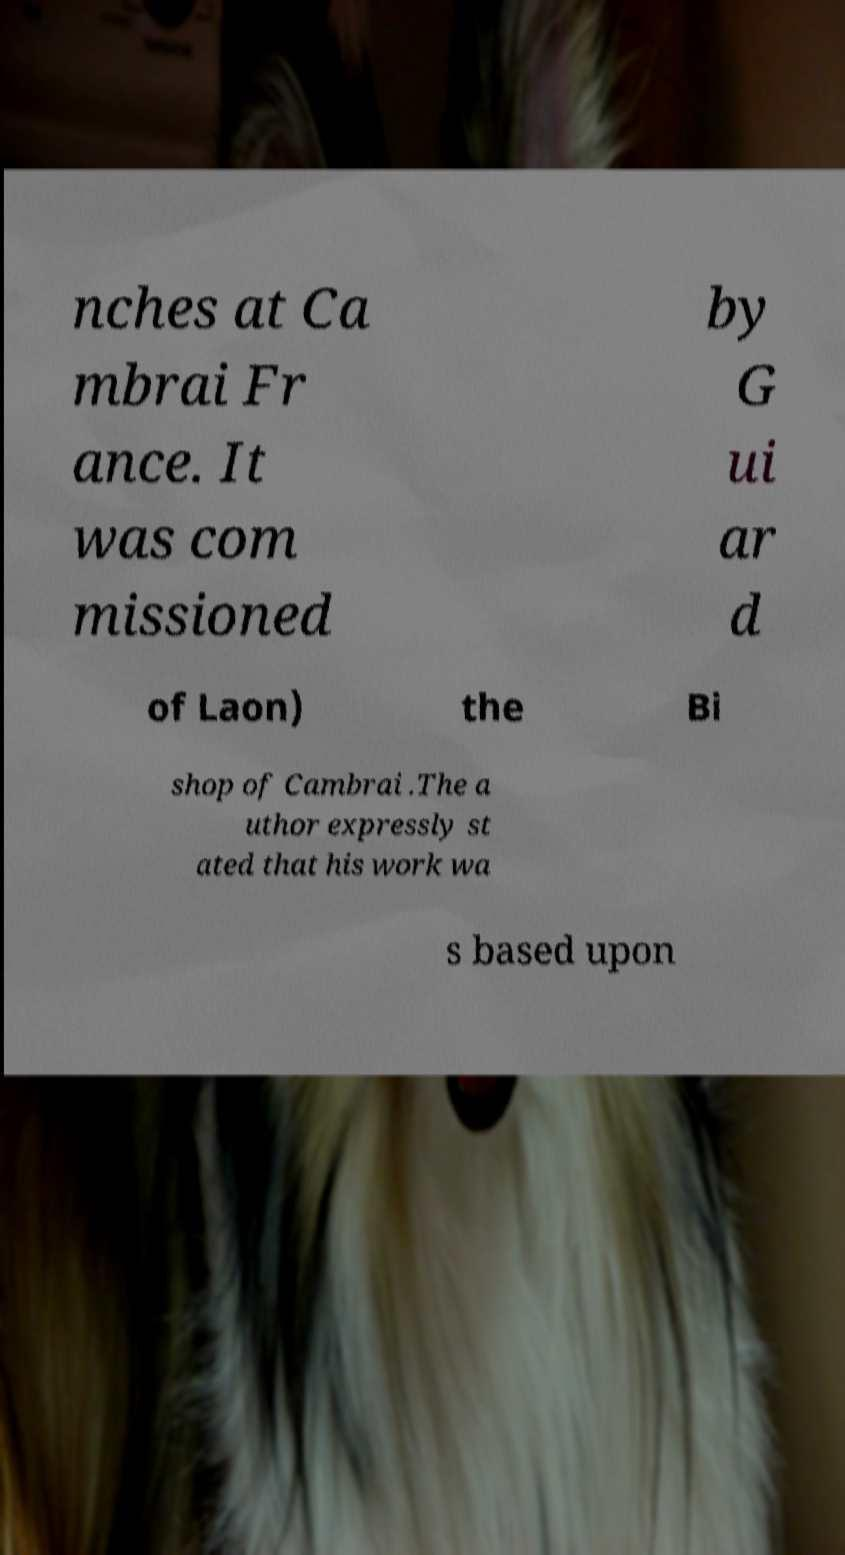I need the written content from this picture converted into text. Can you do that? nches at Ca mbrai Fr ance. It was com missioned by G ui ar d of Laon) the Bi shop of Cambrai .The a uthor expressly st ated that his work wa s based upon 